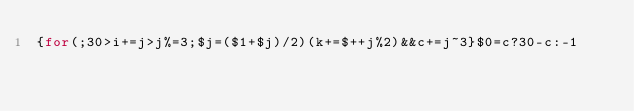Convert code to text. <code><loc_0><loc_0><loc_500><loc_500><_Awk_>{for(;30>i+=j>j%=3;$j=($1+$j)/2)(k+=$++j%2)&&c+=j~3}$0=c?30-c:-1</code> 